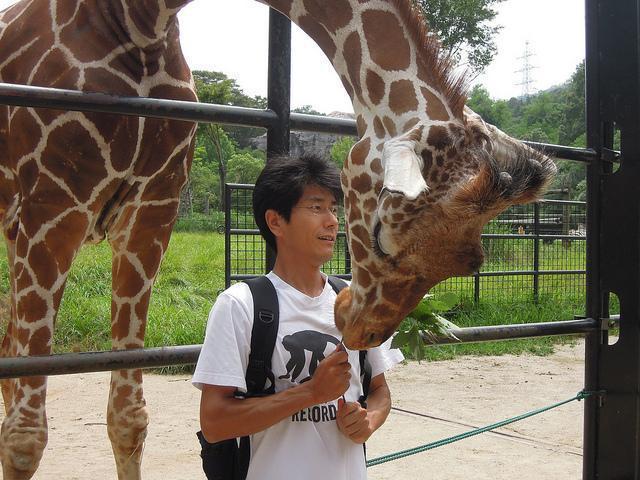How many people are there?
Give a very brief answer. 1. 